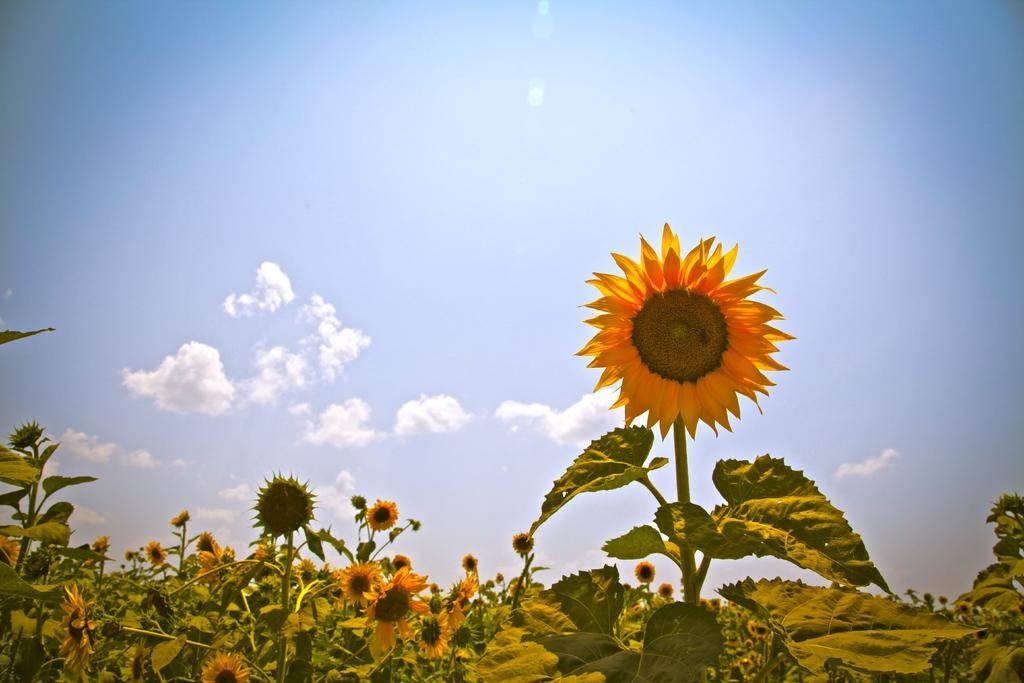Could you give a brief overview of what you see in this image? In this images we can see sunflowers on the plants. In the background there is sky with clouds. 